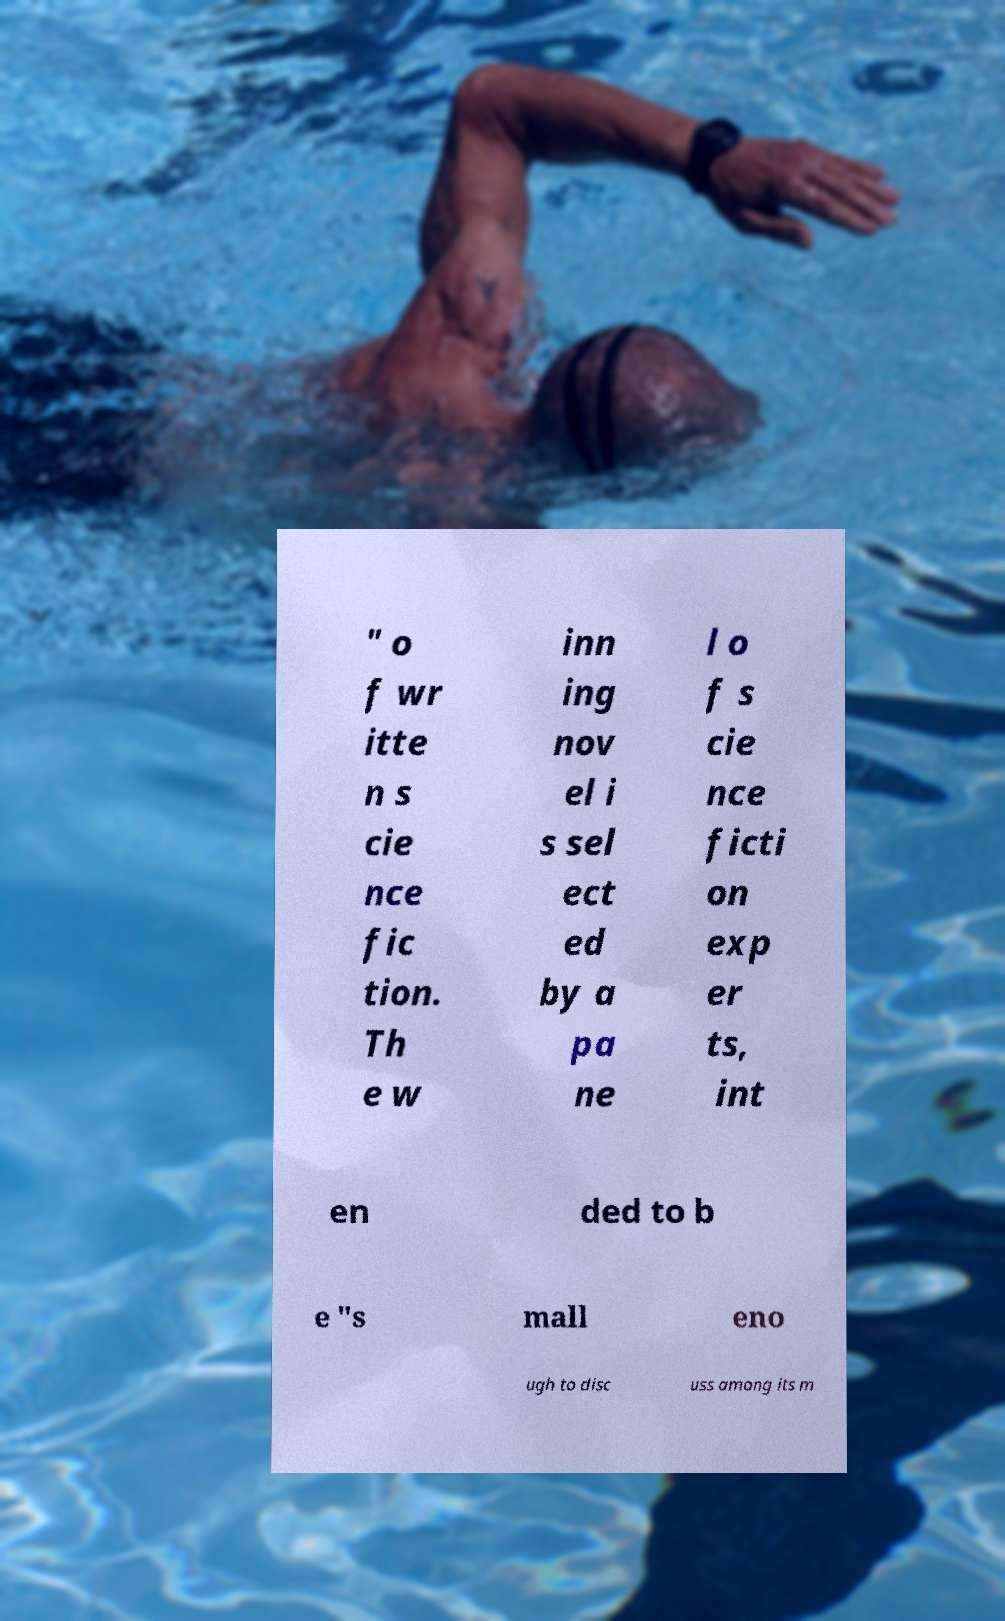For documentation purposes, I need the text within this image transcribed. Could you provide that? " o f wr itte n s cie nce fic tion. Th e w inn ing nov el i s sel ect ed by a pa ne l o f s cie nce ficti on exp er ts, int en ded to b e "s mall eno ugh to disc uss among its m 